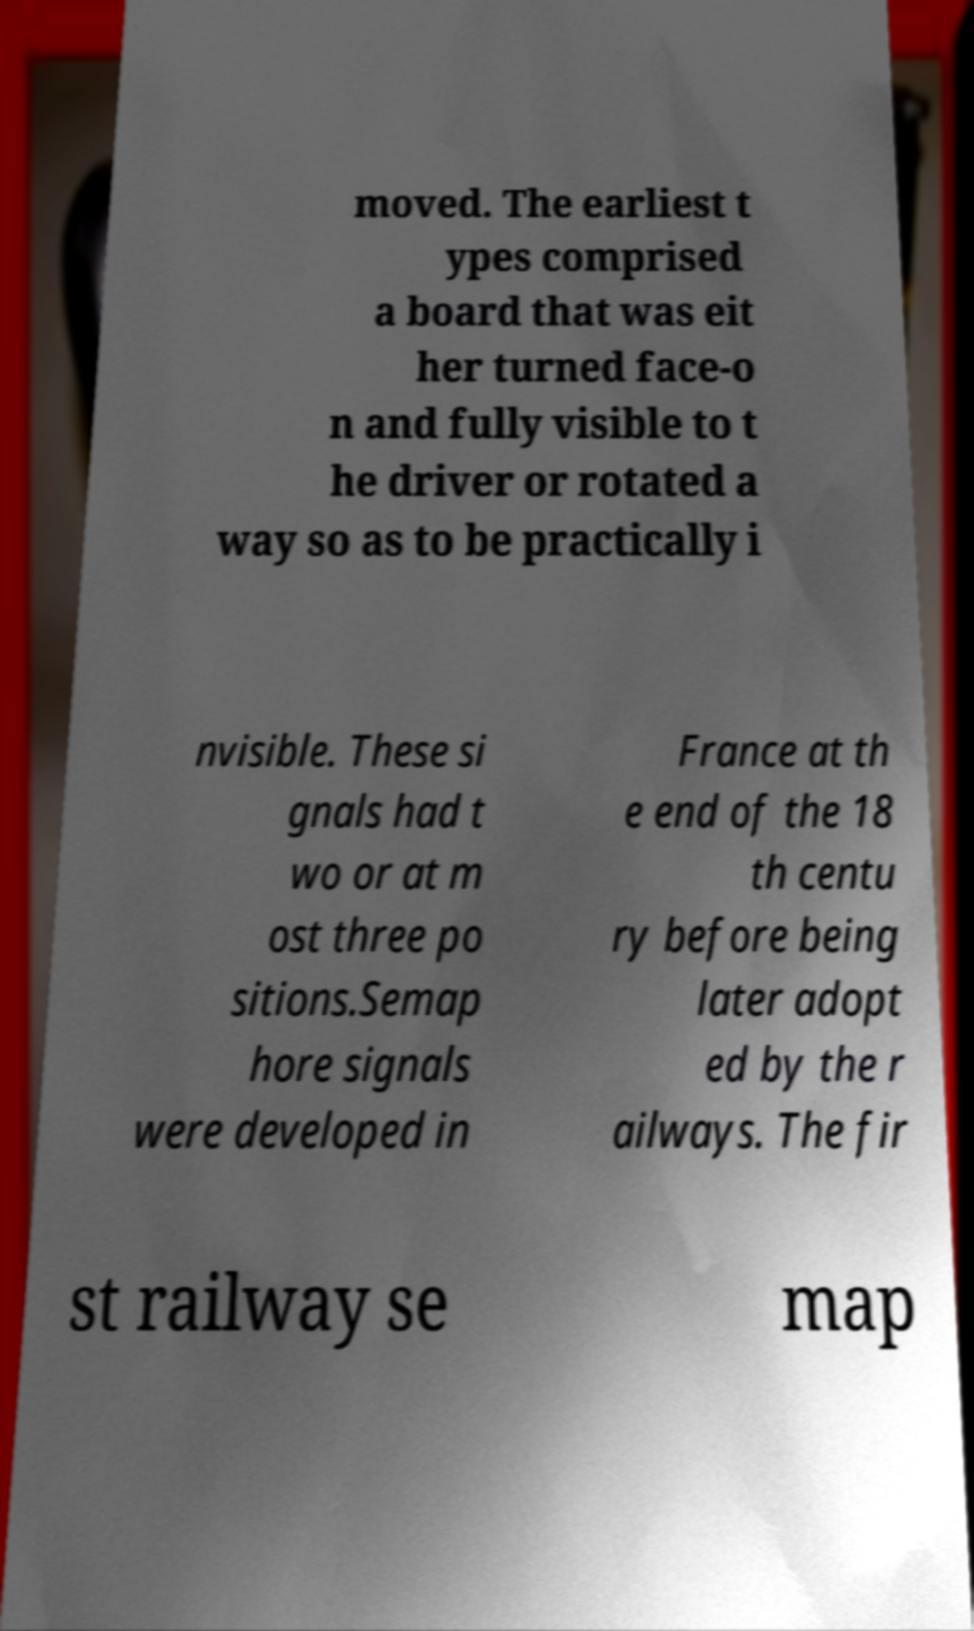There's text embedded in this image that I need extracted. Can you transcribe it verbatim? moved. The earliest t ypes comprised a board that was eit her turned face-o n and fully visible to t he driver or rotated a way so as to be practically i nvisible. These si gnals had t wo or at m ost three po sitions.Semap hore signals were developed in France at th e end of the 18 th centu ry before being later adopt ed by the r ailways. The fir st railway se map 